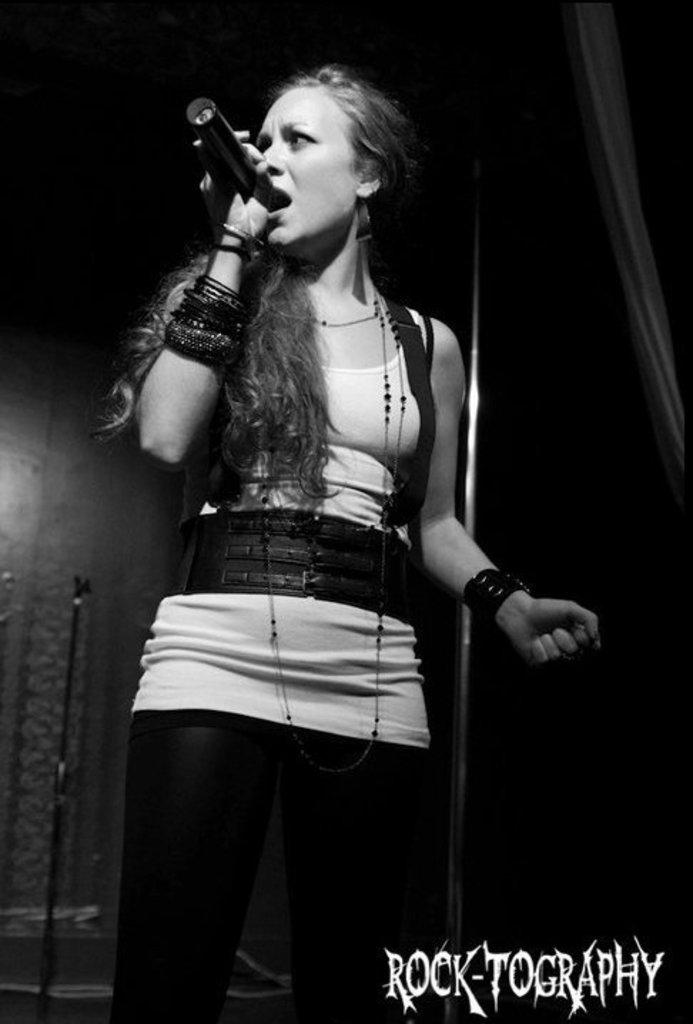Who is the main subject in the image? There is a woman in the image. What is the woman doing in the image? The woman is singing. What object is the woman holding in the image? The woman is holding a mic. What type of texture can be seen on the rifle in the image? There is no rifle present in the image; the woman is holding a mic. How is the whip being used by the woman in the image? There is no whip present in the image; the woman is singing and holding a mic. 